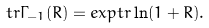<formula> <loc_0><loc_0><loc_500><loc_500>t r \Gamma _ { - 1 } ( R ) = e x p t r \ln ( 1 + R ) .</formula> 